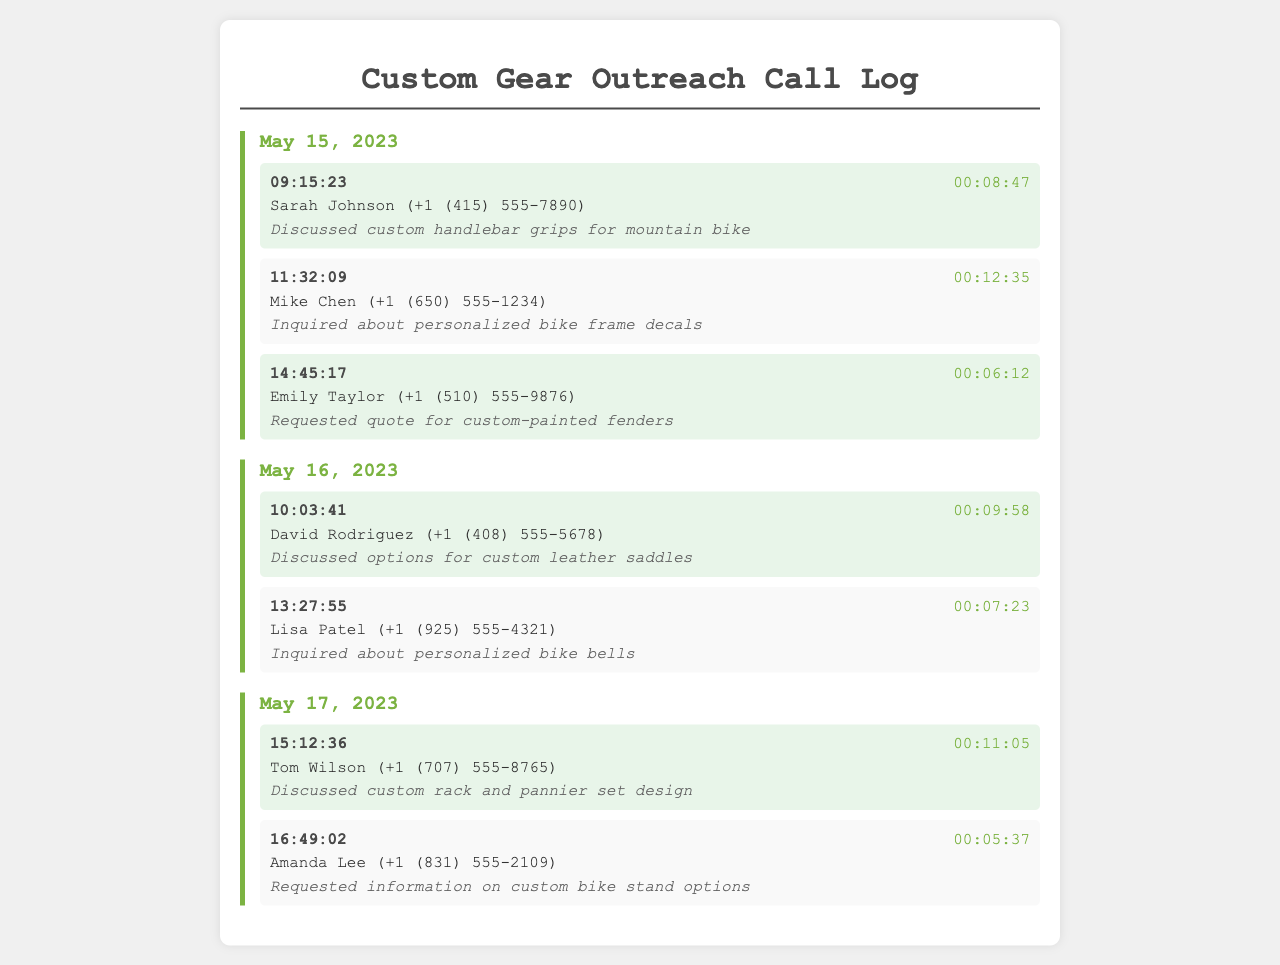what was the duration of the call with Sarah Johnson? The duration is provided in the call entry for Sarah Johnson, which is 00:08:47.
Answer: 00:08:47 what time did Mike Chen's call take place? The call entry lists the time for Mike Chen's call as 11:32:09.
Answer: 11:32:09 how many calls were made on May 15, 2023? The document shows three call entries for May 15, indicating the total number of calls made that day.
Answer: 3 who inquired about personalized bike bells? The call entry for Lisa Patel notes her inquiry about personalized bike bells.
Answer: Lisa Patel which custom gear was discussed in the call with David Rodriguez? The notes for David Rodriguez's call indicate a discussion of custom leather saddles.
Answer: custom leather saddles what is the total length of calls logged on May 17, 2023? The total length of all calls for that day needs to be calculated based on the individual call durations provided in the entries.
Answer: 00:16:42 who requested information on custom bike stand options? The call entry indicates that Amanda Lee requested this information during her call.
Answer: Amanda Lee when did the last call occur? The last call recorded is from Amanda Lee on May 17, 2023, at 16:49:02.
Answer: May 17, 2023, 16:49:02 